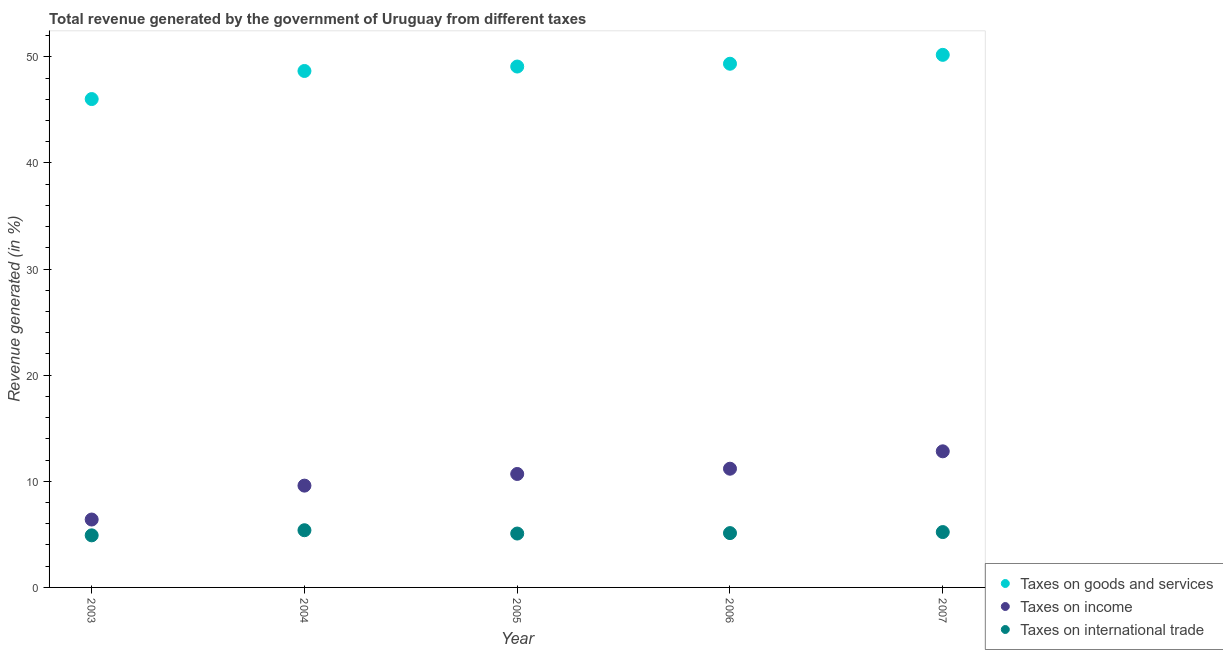What is the percentage of revenue generated by taxes on income in 2006?
Keep it short and to the point. 11.19. Across all years, what is the maximum percentage of revenue generated by taxes on income?
Your response must be concise. 12.83. Across all years, what is the minimum percentage of revenue generated by tax on international trade?
Offer a very short reply. 4.91. In which year was the percentage of revenue generated by taxes on goods and services minimum?
Provide a succinct answer. 2003. What is the total percentage of revenue generated by taxes on goods and services in the graph?
Offer a terse response. 243.33. What is the difference between the percentage of revenue generated by taxes on goods and services in 2005 and that in 2007?
Give a very brief answer. -1.1. What is the difference between the percentage of revenue generated by taxes on goods and services in 2004 and the percentage of revenue generated by tax on international trade in 2005?
Ensure brevity in your answer.  43.59. What is the average percentage of revenue generated by taxes on income per year?
Offer a terse response. 10.14. In the year 2005, what is the difference between the percentage of revenue generated by taxes on goods and services and percentage of revenue generated by tax on international trade?
Ensure brevity in your answer.  44.01. In how many years, is the percentage of revenue generated by taxes on goods and services greater than 2 %?
Your answer should be very brief. 5. What is the ratio of the percentage of revenue generated by taxes on goods and services in 2003 to that in 2006?
Ensure brevity in your answer.  0.93. What is the difference between the highest and the second highest percentage of revenue generated by taxes on income?
Provide a short and direct response. 1.64. What is the difference between the highest and the lowest percentage of revenue generated by tax on international trade?
Make the answer very short. 0.48. In how many years, is the percentage of revenue generated by tax on international trade greater than the average percentage of revenue generated by tax on international trade taken over all years?
Your response must be concise. 2. Is the sum of the percentage of revenue generated by tax on international trade in 2005 and 2007 greater than the maximum percentage of revenue generated by taxes on goods and services across all years?
Make the answer very short. No. Is it the case that in every year, the sum of the percentage of revenue generated by taxes on goods and services and percentage of revenue generated by taxes on income is greater than the percentage of revenue generated by tax on international trade?
Your response must be concise. Yes. Does the percentage of revenue generated by taxes on income monotonically increase over the years?
Offer a terse response. Yes. How many years are there in the graph?
Offer a terse response. 5. What is the difference between two consecutive major ticks on the Y-axis?
Provide a short and direct response. 10. Does the graph contain any zero values?
Your answer should be compact. No. Does the graph contain grids?
Make the answer very short. No. How are the legend labels stacked?
Your answer should be very brief. Vertical. What is the title of the graph?
Make the answer very short. Total revenue generated by the government of Uruguay from different taxes. What is the label or title of the X-axis?
Make the answer very short. Year. What is the label or title of the Y-axis?
Give a very brief answer. Revenue generated (in %). What is the Revenue generated (in %) of Taxes on goods and services in 2003?
Provide a succinct answer. 46.03. What is the Revenue generated (in %) of Taxes on income in 2003?
Make the answer very short. 6.4. What is the Revenue generated (in %) in Taxes on international trade in 2003?
Your response must be concise. 4.91. What is the Revenue generated (in %) of Taxes on goods and services in 2004?
Your response must be concise. 48.67. What is the Revenue generated (in %) in Taxes on income in 2004?
Offer a very short reply. 9.59. What is the Revenue generated (in %) of Taxes on international trade in 2004?
Give a very brief answer. 5.39. What is the Revenue generated (in %) in Taxes on goods and services in 2005?
Give a very brief answer. 49.09. What is the Revenue generated (in %) in Taxes on income in 2005?
Offer a terse response. 10.69. What is the Revenue generated (in %) of Taxes on international trade in 2005?
Make the answer very short. 5.08. What is the Revenue generated (in %) in Taxes on goods and services in 2006?
Make the answer very short. 49.35. What is the Revenue generated (in %) of Taxes on income in 2006?
Offer a terse response. 11.19. What is the Revenue generated (in %) in Taxes on international trade in 2006?
Give a very brief answer. 5.12. What is the Revenue generated (in %) of Taxes on goods and services in 2007?
Keep it short and to the point. 50.19. What is the Revenue generated (in %) in Taxes on income in 2007?
Ensure brevity in your answer.  12.83. What is the Revenue generated (in %) in Taxes on international trade in 2007?
Provide a succinct answer. 5.22. Across all years, what is the maximum Revenue generated (in %) of Taxes on goods and services?
Offer a very short reply. 50.19. Across all years, what is the maximum Revenue generated (in %) in Taxes on income?
Offer a very short reply. 12.83. Across all years, what is the maximum Revenue generated (in %) of Taxes on international trade?
Offer a terse response. 5.39. Across all years, what is the minimum Revenue generated (in %) of Taxes on goods and services?
Your response must be concise. 46.03. Across all years, what is the minimum Revenue generated (in %) of Taxes on income?
Offer a terse response. 6.4. Across all years, what is the minimum Revenue generated (in %) of Taxes on international trade?
Your answer should be very brief. 4.91. What is the total Revenue generated (in %) in Taxes on goods and services in the graph?
Offer a terse response. 243.33. What is the total Revenue generated (in %) in Taxes on income in the graph?
Offer a very short reply. 50.7. What is the total Revenue generated (in %) of Taxes on international trade in the graph?
Offer a terse response. 25.71. What is the difference between the Revenue generated (in %) of Taxes on goods and services in 2003 and that in 2004?
Offer a terse response. -2.65. What is the difference between the Revenue generated (in %) in Taxes on income in 2003 and that in 2004?
Provide a short and direct response. -3.19. What is the difference between the Revenue generated (in %) of Taxes on international trade in 2003 and that in 2004?
Your answer should be compact. -0.48. What is the difference between the Revenue generated (in %) of Taxes on goods and services in 2003 and that in 2005?
Offer a terse response. -3.06. What is the difference between the Revenue generated (in %) in Taxes on income in 2003 and that in 2005?
Ensure brevity in your answer.  -4.29. What is the difference between the Revenue generated (in %) of Taxes on international trade in 2003 and that in 2005?
Your response must be concise. -0.17. What is the difference between the Revenue generated (in %) in Taxes on goods and services in 2003 and that in 2006?
Provide a short and direct response. -3.33. What is the difference between the Revenue generated (in %) of Taxes on income in 2003 and that in 2006?
Offer a terse response. -4.79. What is the difference between the Revenue generated (in %) of Taxes on international trade in 2003 and that in 2006?
Make the answer very short. -0.21. What is the difference between the Revenue generated (in %) of Taxes on goods and services in 2003 and that in 2007?
Give a very brief answer. -4.17. What is the difference between the Revenue generated (in %) in Taxes on income in 2003 and that in 2007?
Your answer should be compact. -6.43. What is the difference between the Revenue generated (in %) of Taxes on international trade in 2003 and that in 2007?
Provide a succinct answer. -0.31. What is the difference between the Revenue generated (in %) of Taxes on goods and services in 2004 and that in 2005?
Your response must be concise. -0.42. What is the difference between the Revenue generated (in %) in Taxes on income in 2004 and that in 2005?
Offer a very short reply. -1.1. What is the difference between the Revenue generated (in %) of Taxes on international trade in 2004 and that in 2005?
Your answer should be compact. 0.31. What is the difference between the Revenue generated (in %) of Taxes on goods and services in 2004 and that in 2006?
Make the answer very short. -0.68. What is the difference between the Revenue generated (in %) in Taxes on income in 2004 and that in 2006?
Offer a terse response. -1.59. What is the difference between the Revenue generated (in %) of Taxes on international trade in 2004 and that in 2006?
Provide a succinct answer. 0.27. What is the difference between the Revenue generated (in %) in Taxes on goods and services in 2004 and that in 2007?
Provide a short and direct response. -1.52. What is the difference between the Revenue generated (in %) in Taxes on income in 2004 and that in 2007?
Offer a very short reply. -3.23. What is the difference between the Revenue generated (in %) in Taxes on international trade in 2004 and that in 2007?
Provide a succinct answer. 0.17. What is the difference between the Revenue generated (in %) in Taxes on goods and services in 2005 and that in 2006?
Your response must be concise. -0.26. What is the difference between the Revenue generated (in %) of Taxes on income in 2005 and that in 2006?
Ensure brevity in your answer.  -0.5. What is the difference between the Revenue generated (in %) of Taxes on international trade in 2005 and that in 2006?
Provide a succinct answer. -0.04. What is the difference between the Revenue generated (in %) of Taxes on goods and services in 2005 and that in 2007?
Provide a succinct answer. -1.1. What is the difference between the Revenue generated (in %) of Taxes on income in 2005 and that in 2007?
Give a very brief answer. -2.13. What is the difference between the Revenue generated (in %) in Taxes on international trade in 2005 and that in 2007?
Give a very brief answer. -0.14. What is the difference between the Revenue generated (in %) in Taxes on goods and services in 2006 and that in 2007?
Offer a terse response. -0.84. What is the difference between the Revenue generated (in %) in Taxes on income in 2006 and that in 2007?
Ensure brevity in your answer.  -1.64. What is the difference between the Revenue generated (in %) in Taxes on international trade in 2006 and that in 2007?
Give a very brief answer. -0.1. What is the difference between the Revenue generated (in %) in Taxes on goods and services in 2003 and the Revenue generated (in %) in Taxes on income in 2004?
Offer a very short reply. 36.43. What is the difference between the Revenue generated (in %) in Taxes on goods and services in 2003 and the Revenue generated (in %) in Taxes on international trade in 2004?
Offer a very short reply. 40.63. What is the difference between the Revenue generated (in %) of Taxes on income in 2003 and the Revenue generated (in %) of Taxes on international trade in 2004?
Your answer should be compact. 1.01. What is the difference between the Revenue generated (in %) of Taxes on goods and services in 2003 and the Revenue generated (in %) of Taxes on income in 2005?
Give a very brief answer. 35.33. What is the difference between the Revenue generated (in %) in Taxes on goods and services in 2003 and the Revenue generated (in %) in Taxes on international trade in 2005?
Your answer should be compact. 40.95. What is the difference between the Revenue generated (in %) in Taxes on income in 2003 and the Revenue generated (in %) in Taxes on international trade in 2005?
Offer a terse response. 1.32. What is the difference between the Revenue generated (in %) in Taxes on goods and services in 2003 and the Revenue generated (in %) in Taxes on income in 2006?
Make the answer very short. 34.84. What is the difference between the Revenue generated (in %) of Taxes on goods and services in 2003 and the Revenue generated (in %) of Taxes on international trade in 2006?
Provide a succinct answer. 40.91. What is the difference between the Revenue generated (in %) of Taxes on income in 2003 and the Revenue generated (in %) of Taxes on international trade in 2006?
Your answer should be very brief. 1.28. What is the difference between the Revenue generated (in %) of Taxes on goods and services in 2003 and the Revenue generated (in %) of Taxes on income in 2007?
Keep it short and to the point. 33.2. What is the difference between the Revenue generated (in %) of Taxes on goods and services in 2003 and the Revenue generated (in %) of Taxes on international trade in 2007?
Offer a terse response. 40.81. What is the difference between the Revenue generated (in %) in Taxes on income in 2003 and the Revenue generated (in %) in Taxes on international trade in 2007?
Offer a terse response. 1.18. What is the difference between the Revenue generated (in %) in Taxes on goods and services in 2004 and the Revenue generated (in %) in Taxes on income in 2005?
Your response must be concise. 37.98. What is the difference between the Revenue generated (in %) of Taxes on goods and services in 2004 and the Revenue generated (in %) of Taxes on international trade in 2005?
Provide a succinct answer. 43.59. What is the difference between the Revenue generated (in %) in Taxes on income in 2004 and the Revenue generated (in %) in Taxes on international trade in 2005?
Offer a very short reply. 4.52. What is the difference between the Revenue generated (in %) in Taxes on goods and services in 2004 and the Revenue generated (in %) in Taxes on income in 2006?
Provide a succinct answer. 37.48. What is the difference between the Revenue generated (in %) of Taxes on goods and services in 2004 and the Revenue generated (in %) of Taxes on international trade in 2006?
Your answer should be very brief. 43.55. What is the difference between the Revenue generated (in %) of Taxes on income in 2004 and the Revenue generated (in %) of Taxes on international trade in 2006?
Make the answer very short. 4.47. What is the difference between the Revenue generated (in %) in Taxes on goods and services in 2004 and the Revenue generated (in %) in Taxes on income in 2007?
Provide a short and direct response. 35.84. What is the difference between the Revenue generated (in %) in Taxes on goods and services in 2004 and the Revenue generated (in %) in Taxes on international trade in 2007?
Offer a terse response. 43.46. What is the difference between the Revenue generated (in %) in Taxes on income in 2004 and the Revenue generated (in %) in Taxes on international trade in 2007?
Keep it short and to the point. 4.38. What is the difference between the Revenue generated (in %) of Taxes on goods and services in 2005 and the Revenue generated (in %) of Taxes on income in 2006?
Make the answer very short. 37.9. What is the difference between the Revenue generated (in %) of Taxes on goods and services in 2005 and the Revenue generated (in %) of Taxes on international trade in 2006?
Your response must be concise. 43.97. What is the difference between the Revenue generated (in %) in Taxes on income in 2005 and the Revenue generated (in %) in Taxes on international trade in 2006?
Your answer should be very brief. 5.57. What is the difference between the Revenue generated (in %) of Taxes on goods and services in 2005 and the Revenue generated (in %) of Taxes on income in 2007?
Your response must be concise. 36.26. What is the difference between the Revenue generated (in %) in Taxes on goods and services in 2005 and the Revenue generated (in %) in Taxes on international trade in 2007?
Your answer should be compact. 43.87. What is the difference between the Revenue generated (in %) in Taxes on income in 2005 and the Revenue generated (in %) in Taxes on international trade in 2007?
Make the answer very short. 5.48. What is the difference between the Revenue generated (in %) of Taxes on goods and services in 2006 and the Revenue generated (in %) of Taxes on income in 2007?
Your answer should be very brief. 36.53. What is the difference between the Revenue generated (in %) of Taxes on goods and services in 2006 and the Revenue generated (in %) of Taxes on international trade in 2007?
Your response must be concise. 44.14. What is the difference between the Revenue generated (in %) in Taxes on income in 2006 and the Revenue generated (in %) in Taxes on international trade in 2007?
Make the answer very short. 5.97. What is the average Revenue generated (in %) of Taxes on goods and services per year?
Your response must be concise. 48.67. What is the average Revenue generated (in %) of Taxes on income per year?
Your response must be concise. 10.14. What is the average Revenue generated (in %) in Taxes on international trade per year?
Your answer should be very brief. 5.14. In the year 2003, what is the difference between the Revenue generated (in %) of Taxes on goods and services and Revenue generated (in %) of Taxes on income?
Your answer should be very brief. 39.63. In the year 2003, what is the difference between the Revenue generated (in %) in Taxes on goods and services and Revenue generated (in %) in Taxes on international trade?
Your response must be concise. 41.12. In the year 2003, what is the difference between the Revenue generated (in %) of Taxes on income and Revenue generated (in %) of Taxes on international trade?
Keep it short and to the point. 1.49. In the year 2004, what is the difference between the Revenue generated (in %) in Taxes on goods and services and Revenue generated (in %) in Taxes on income?
Provide a succinct answer. 39.08. In the year 2004, what is the difference between the Revenue generated (in %) of Taxes on goods and services and Revenue generated (in %) of Taxes on international trade?
Your response must be concise. 43.28. In the year 2004, what is the difference between the Revenue generated (in %) of Taxes on income and Revenue generated (in %) of Taxes on international trade?
Make the answer very short. 4.2. In the year 2005, what is the difference between the Revenue generated (in %) in Taxes on goods and services and Revenue generated (in %) in Taxes on income?
Keep it short and to the point. 38.4. In the year 2005, what is the difference between the Revenue generated (in %) in Taxes on goods and services and Revenue generated (in %) in Taxes on international trade?
Give a very brief answer. 44.01. In the year 2005, what is the difference between the Revenue generated (in %) in Taxes on income and Revenue generated (in %) in Taxes on international trade?
Make the answer very short. 5.61. In the year 2006, what is the difference between the Revenue generated (in %) in Taxes on goods and services and Revenue generated (in %) in Taxes on income?
Provide a short and direct response. 38.17. In the year 2006, what is the difference between the Revenue generated (in %) in Taxes on goods and services and Revenue generated (in %) in Taxes on international trade?
Your response must be concise. 44.23. In the year 2006, what is the difference between the Revenue generated (in %) of Taxes on income and Revenue generated (in %) of Taxes on international trade?
Provide a succinct answer. 6.07. In the year 2007, what is the difference between the Revenue generated (in %) of Taxes on goods and services and Revenue generated (in %) of Taxes on income?
Provide a short and direct response. 37.37. In the year 2007, what is the difference between the Revenue generated (in %) in Taxes on goods and services and Revenue generated (in %) in Taxes on international trade?
Offer a terse response. 44.98. In the year 2007, what is the difference between the Revenue generated (in %) of Taxes on income and Revenue generated (in %) of Taxes on international trade?
Your answer should be compact. 7.61. What is the ratio of the Revenue generated (in %) in Taxes on goods and services in 2003 to that in 2004?
Keep it short and to the point. 0.95. What is the ratio of the Revenue generated (in %) of Taxes on income in 2003 to that in 2004?
Offer a terse response. 0.67. What is the ratio of the Revenue generated (in %) in Taxes on international trade in 2003 to that in 2004?
Provide a short and direct response. 0.91. What is the ratio of the Revenue generated (in %) in Taxes on goods and services in 2003 to that in 2005?
Ensure brevity in your answer.  0.94. What is the ratio of the Revenue generated (in %) in Taxes on income in 2003 to that in 2005?
Offer a very short reply. 0.6. What is the ratio of the Revenue generated (in %) in Taxes on international trade in 2003 to that in 2005?
Keep it short and to the point. 0.97. What is the ratio of the Revenue generated (in %) in Taxes on goods and services in 2003 to that in 2006?
Keep it short and to the point. 0.93. What is the ratio of the Revenue generated (in %) in Taxes on income in 2003 to that in 2006?
Give a very brief answer. 0.57. What is the ratio of the Revenue generated (in %) in Taxes on international trade in 2003 to that in 2006?
Provide a succinct answer. 0.96. What is the ratio of the Revenue generated (in %) of Taxes on goods and services in 2003 to that in 2007?
Offer a terse response. 0.92. What is the ratio of the Revenue generated (in %) of Taxes on income in 2003 to that in 2007?
Provide a succinct answer. 0.5. What is the ratio of the Revenue generated (in %) in Taxes on international trade in 2003 to that in 2007?
Make the answer very short. 0.94. What is the ratio of the Revenue generated (in %) of Taxes on goods and services in 2004 to that in 2005?
Give a very brief answer. 0.99. What is the ratio of the Revenue generated (in %) in Taxes on income in 2004 to that in 2005?
Your answer should be compact. 0.9. What is the ratio of the Revenue generated (in %) in Taxes on international trade in 2004 to that in 2005?
Your answer should be very brief. 1.06. What is the ratio of the Revenue generated (in %) in Taxes on goods and services in 2004 to that in 2006?
Your answer should be compact. 0.99. What is the ratio of the Revenue generated (in %) of Taxes on income in 2004 to that in 2006?
Make the answer very short. 0.86. What is the ratio of the Revenue generated (in %) of Taxes on international trade in 2004 to that in 2006?
Give a very brief answer. 1.05. What is the ratio of the Revenue generated (in %) in Taxes on goods and services in 2004 to that in 2007?
Your answer should be very brief. 0.97. What is the ratio of the Revenue generated (in %) in Taxes on income in 2004 to that in 2007?
Offer a terse response. 0.75. What is the ratio of the Revenue generated (in %) of Taxes on international trade in 2004 to that in 2007?
Your response must be concise. 1.03. What is the ratio of the Revenue generated (in %) in Taxes on goods and services in 2005 to that in 2006?
Provide a succinct answer. 0.99. What is the ratio of the Revenue generated (in %) in Taxes on income in 2005 to that in 2006?
Offer a terse response. 0.96. What is the ratio of the Revenue generated (in %) of Taxes on goods and services in 2005 to that in 2007?
Give a very brief answer. 0.98. What is the ratio of the Revenue generated (in %) of Taxes on income in 2005 to that in 2007?
Your answer should be compact. 0.83. What is the ratio of the Revenue generated (in %) in Taxes on international trade in 2005 to that in 2007?
Your answer should be compact. 0.97. What is the ratio of the Revenue generated (in %) of Taxes on goods and services in 2006 to that in 2007?
Keep it short and to the point. 0.98. What is the ratio of the Revenue generated (in %) in Taxes on income in 2006 to that in 2007?
Ensure brevity in your answer.  0.87. What is the ratio of the Revenue generated (in %) in Taxes on international trade in 2006 to that in 2007?
Your answer should be very brief. 0.98. What is the difference between the highest and the second highest Revenue generated (in %) in Taxes on goods and services?
Offer a terse response. 0.84. What is the difference between the highest and the second highest Revenue generated (in %) in Taxes on income?
Your answer should be very brief. 1.64. What is the difference between the highest and the second highest Revenue generated (in %) in Taxes on international trade?
Provide a succinct answer. 0.17. What is the difference between the highest and the lowest Revenue generated (in %) in Taxes on goods and services?
Your answer should be compact. 4.17. What is the difference between the highest and the lowest Revenue generated (in %) in Taxes on income?
Your answer should be very brief. 6.43. What is the difference between the highest and the lowest Revenue generated (in %) in Taxes on international trade?
Make the answer very short. 0.48. 